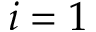<formula> <loc_0><loc_0><loc_500><loc_500>i = 1</formula> 